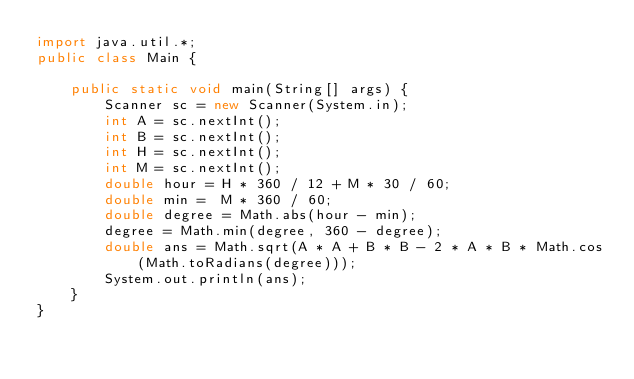Convert code to text. <code><loc_0><loc_0><loc_500><loc_500><_Java_>import java.util.*;
public class Main {

    public static void main(String[] args) {
        Scanner sc = new Scanner(System.in);
        int A = sc.nextInt();
        int B = sc.nextInt();
        int H = sc.nextInt();
        int M = sc.nextInt();
        double hour = H * 360 / 12 + M * 30 / 60;
        double min =  M * 360 / 60;
        double degree = Math.abs(hour - min);
        degree = Math.min(degree, 360 - degree);
        double ans = Math.sqrt(A * A + B * B - 2 * A * B * Math.cos(Math.toRadians(degree)));
        System.out.println(ans);
    }
}
</code> 